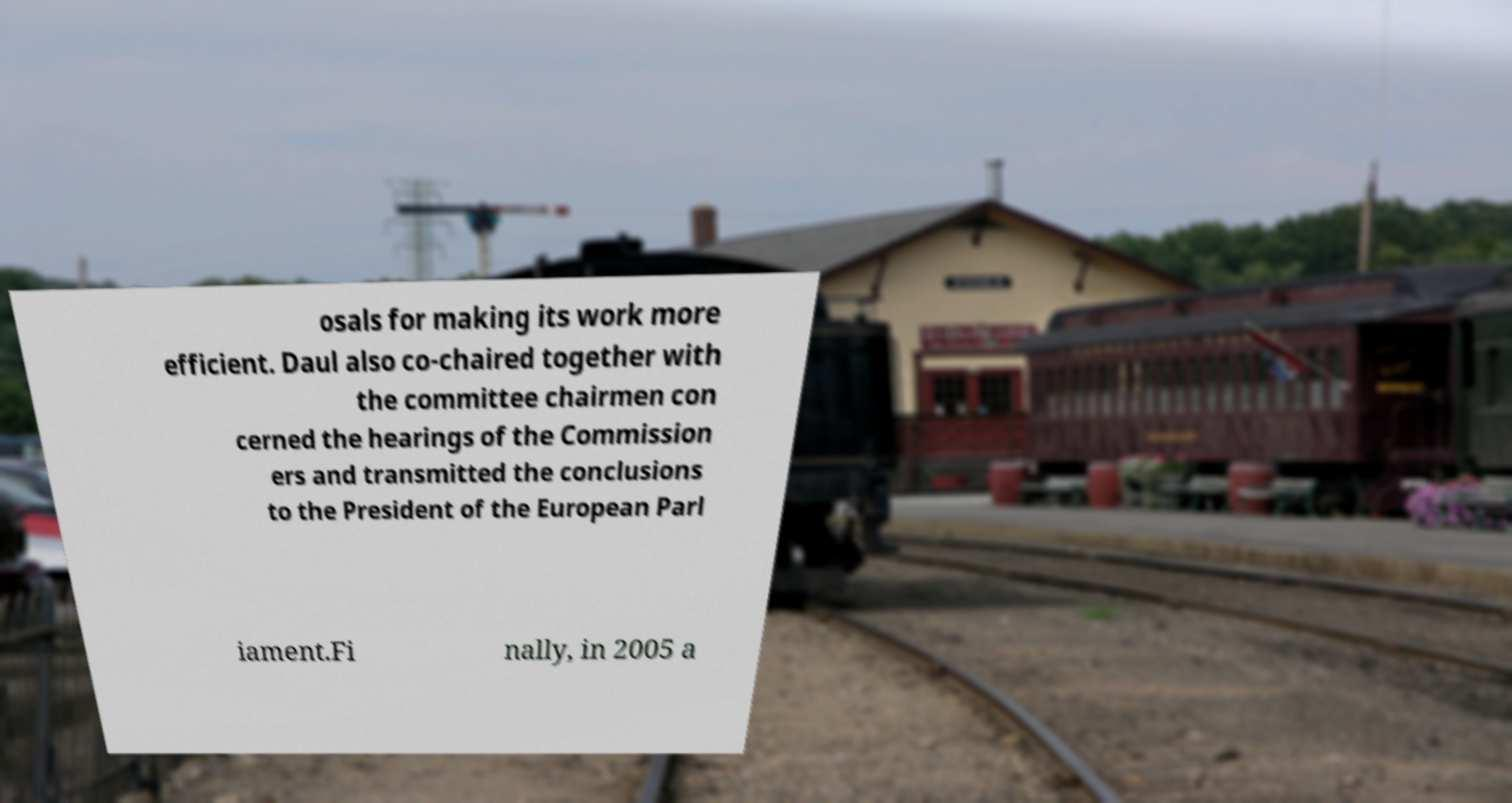Can you read and provide the text displayed in the image?This photo seems to have some interesting text. Can you extract and type it out for me? osals for making its work more efficient. Daul also co-chaired together with the committee chairmen con cerned the hearings of the Commission ers and transmitted the conclusions to the President of the European Parl iament.Fi nally, in 2005 a 